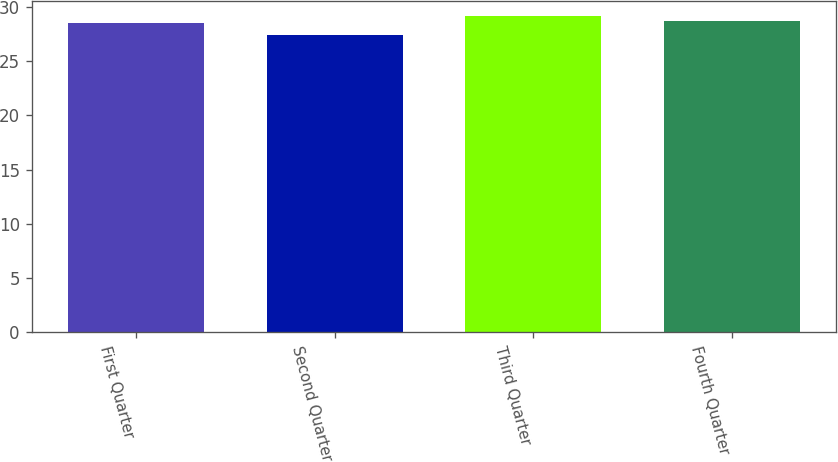Convert chart. <chart><loc_0><loc_0><loc_500><loc_500><bar_chart><fcel>First Quarter<fcel>Second Quarter<fcel>Third Quarter<fcel>Fourth Quarter<nl><fcel>28.53<fcel>27.38<fcel>29.1<fcel>28.7<nl></chart> 